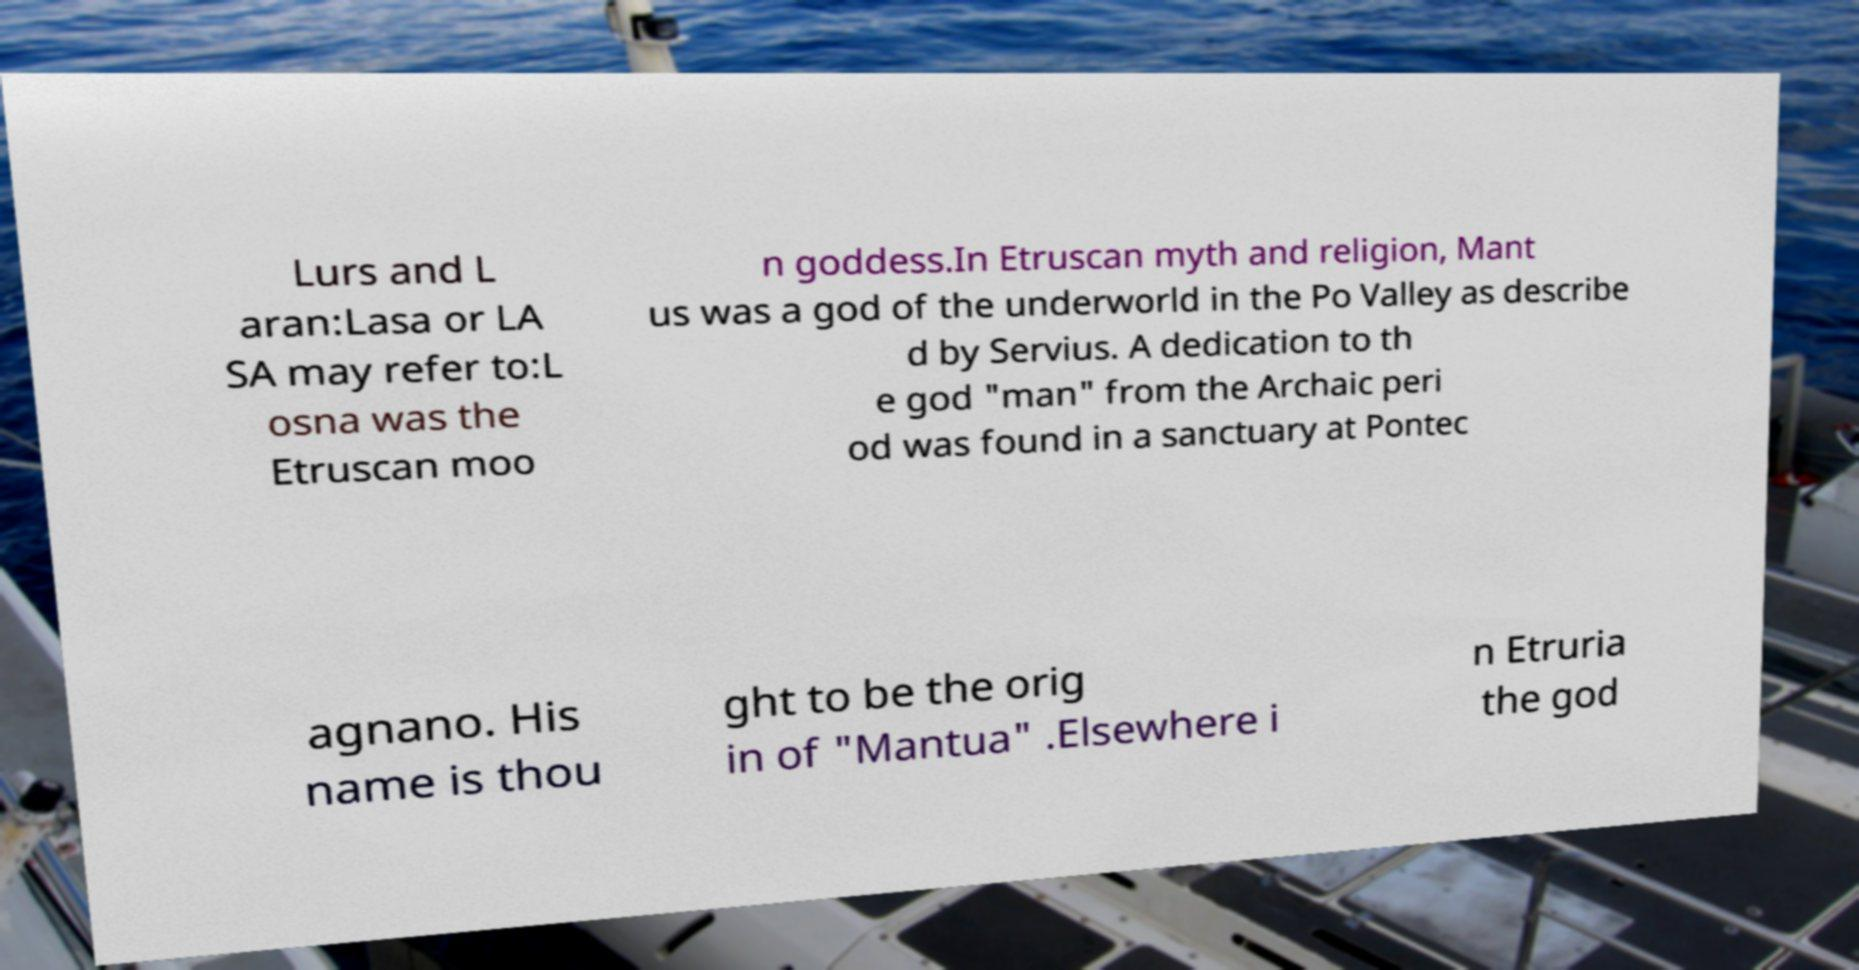Can you read and provide the text displayed in the image?This photo seems to have some interesting text. Can you extract and type it out for me? Lurs and L aran:Lasa or LA SA may refer to:L osna was the Etruscan moo n goddess.In Etruscan myth and religion, Mant us was a god of the underworld in the Po Valley as describe d by Servius. A dedication to th e god "man" from the Archaic peri od was found in a sanctuary at Pontec agnano. His name is thou ght to be the orig in of "Mantua" .Elsewhere i n Etruria the god 